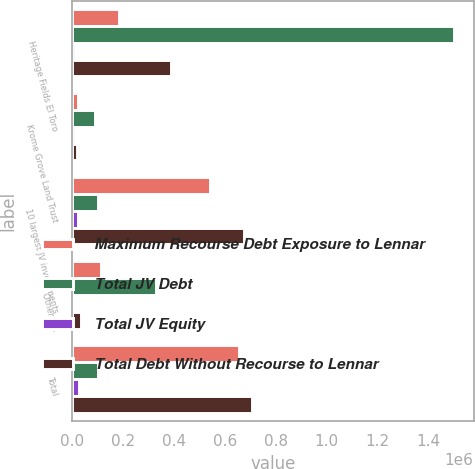Convert chart. <chart><loc_0><loc_0><loc_500><loc_500><stacked_bar_chart><ecel><fcel>Heritage Fields El Toro<fcel>Krome Grove Land Trust<fcel>10 largest JV investments<fcel>Other JVs<fcel>Total<nl><fcel>Maximum Recourse Debt Exposure to Lennar<fcel>182252<fcel>21326<fcel>542927<fcel>113910<fcel>656837<nl><fcel>Total JV Debt<fcel>1.50386e+06<fcel>90622<fcel>102266<fcel>329188<fcel>102266<nl><fcel>Total JV Equity<fcel>11256<fcel>9276<fcel>20532<fcel>3949<fcel>24481<nl><fcel>Total Debt Without Recourse to Lennar<fcel>386608<fcel>19761<fcel>674780<fcel>34203<fcel>708983<nl></chart> 